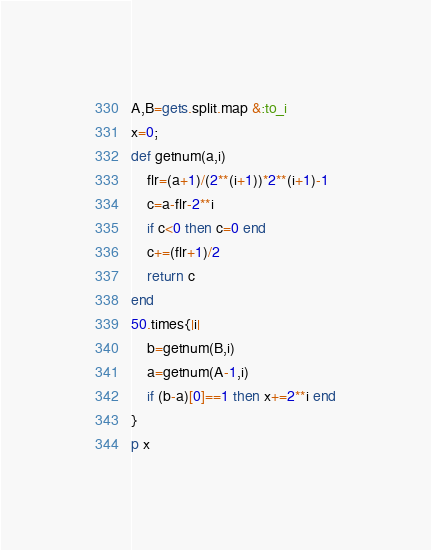Convert code to text. <code><loc_0><loc_0><loc_500><loc_500><_Ruby_>A,B=gets.split.map &:to_i
x=0;
def getnum(a,i)
    flr=(a+1)/(2**(i+1))*2**(i+1)-1
    c=a-flr-2**i
    if c<0 then c=0 end
    c+=(flr+1)/2
    return c
end
50.times{|i|
    b=getnum(B,i)
    a=getnum(A-1,i)
    if (b-a)[0]==1 then x+=2**i end
}
p x</code> 